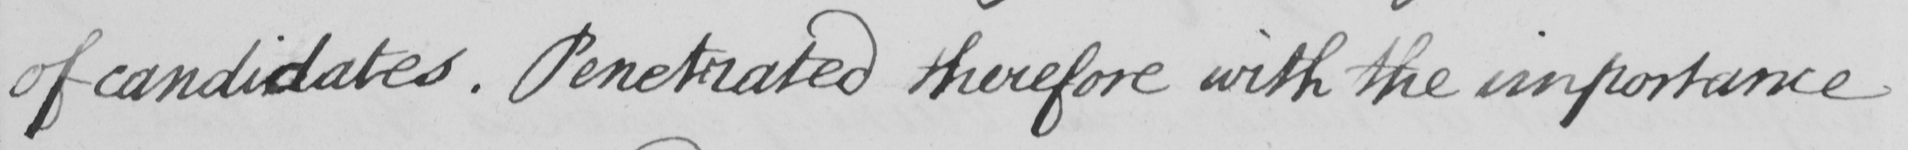Please provide the text content of this handwritten line. of candidates . Penetrated therefore with the importance 